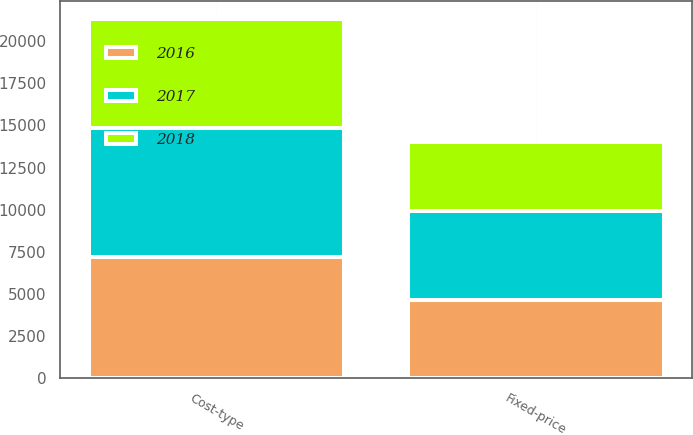<chart> <loc_0><loc_0><loc_500><loc_500><stacked_bar_chart><ecel><fcel>Cost-type<fcel>Fixed-price<nl><fcel>2017<fcel>7634<fcel>5265<nl><fcel>2016<fcel>7193<fcel>4643<nl><fcel>2018<fcel>6484<fcel>4129<nl></chart> 